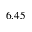<formula> <loc_0><loc_0><loc_500><loc_500>6 . 4 5</formula> 